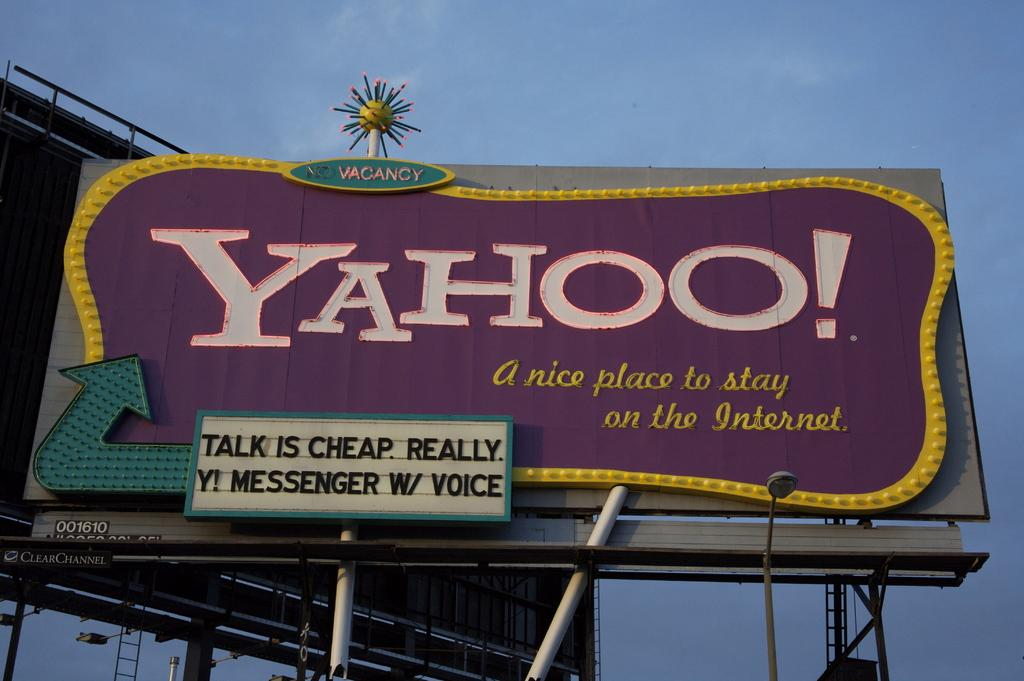<image>
Present a compact description of the photo's key features. A billboard advertising Yahoo says it is a nice place to stay on the internet. 